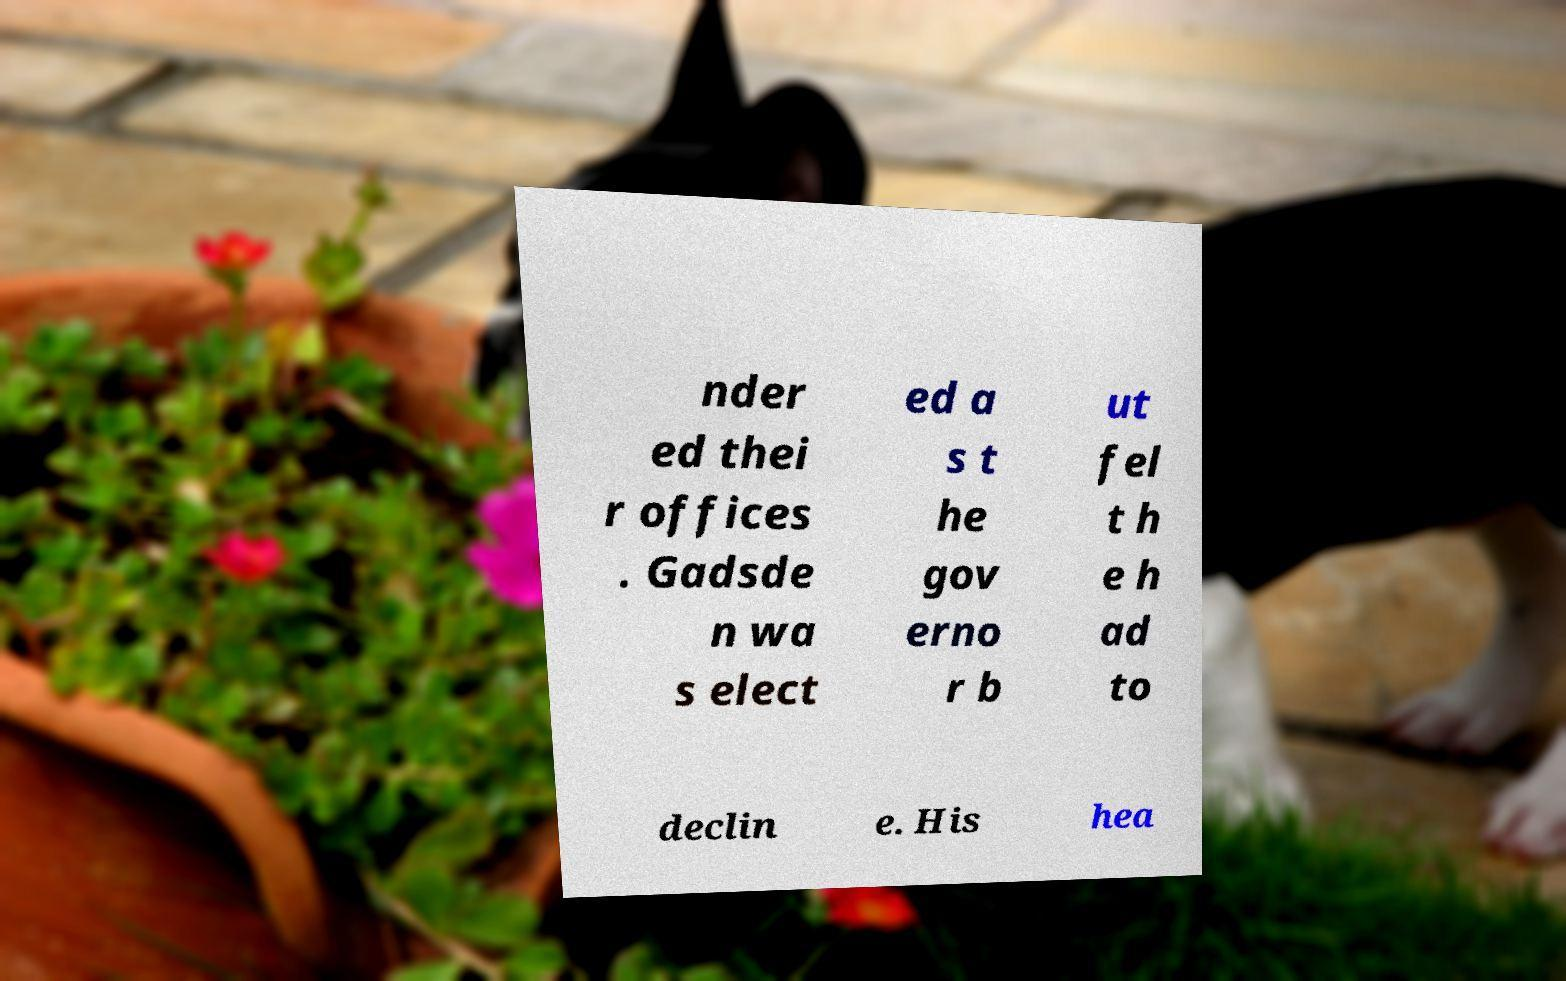Can you read and provide the text displayed in the image?This photo seems to have some interesting text. Can you extract and type it out for me? nder ed thei r offices . Gadsde n wa s elect ed a s t he gov erno r b ut fel t h e h ad to declin e. His hea 